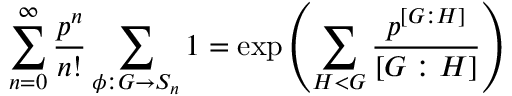Convert formula to latex. <formula><loc_0><loc_0><loc_500><loc_500>\sum _ { n = 0 } ^ { \infty } \frac { p ^ { n } } { n ! } \sum _ { \phi \colon G \rightarrow S _ { n } } 1 = \exp \left ( \sum _ { H < G } \frac { p ^ { \left [ G \colon H \right ] } } { \left [ G \colon H \right ] } \right )</formula> 